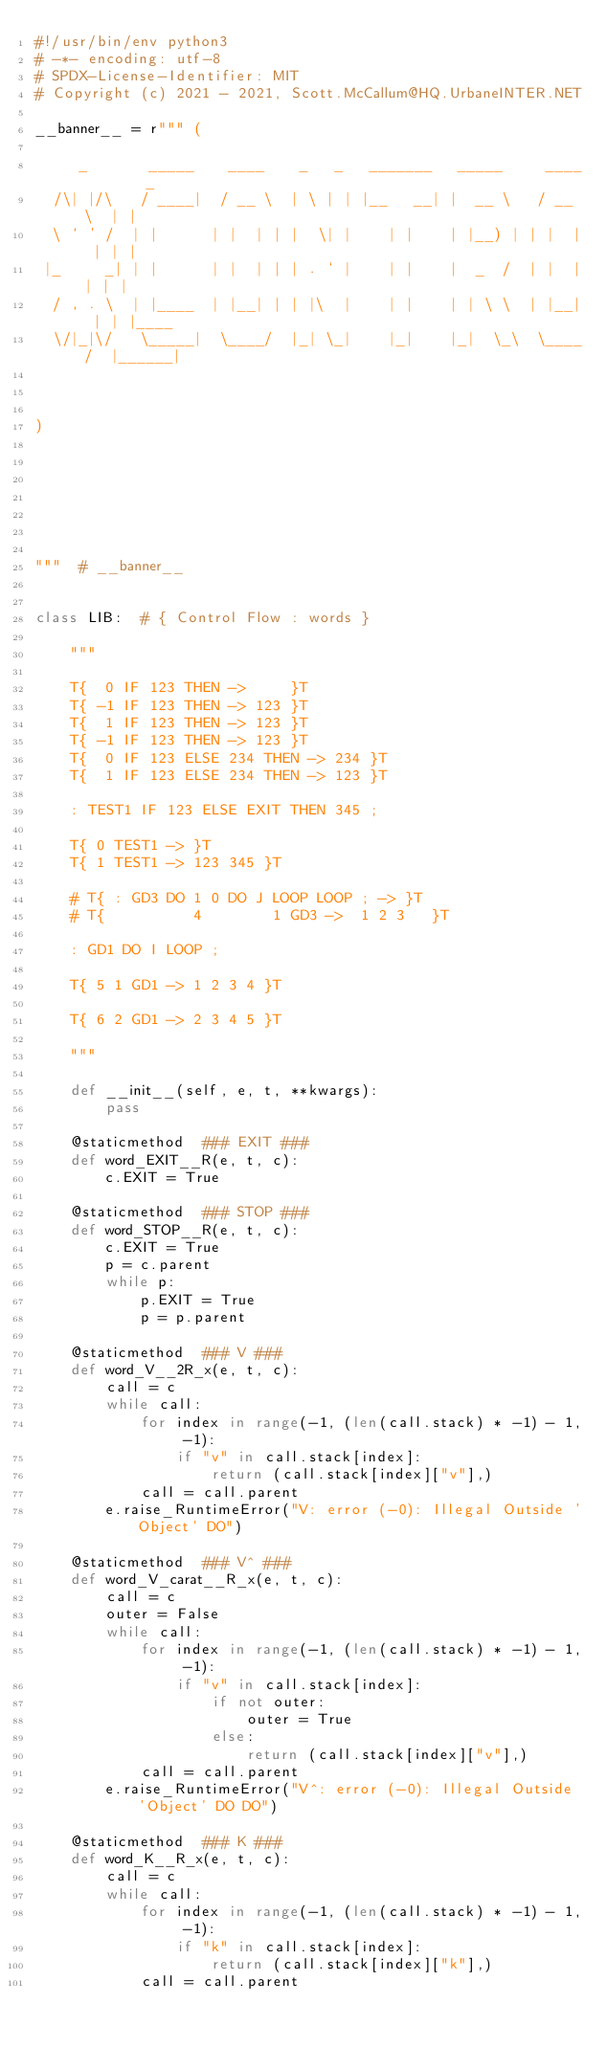Convert code to text. <code><loc_0><loc_0><loc_500><loc_500><_Python_>#!/usr/bin/env python3
# -*- encoding: utf-8
# SPDX-License-Identifier: MIT
# Copyright (c) 2021 - 2021, Scott.McCallum@HQ.UrbaneINTER.NET

__banner__ = r""" (

     _       _____    ____    _   _   _______   _____     ____    _
  /\| |/\   / ____|  / __ \  | \ | | |__   __| |  __ \   / __ \  | |
  \ ` ' /  | |      | |  | | |  \| |    | |    | |__) | | |  | | | |
 |_     _| | |      | |  | | | . ` |    | |    |  _  /  | |  | | | |
  / , . \  | |____  | |__| | | |\  |    | |    | | \ \  | |__| | | |____
  \/|_|\/   \_____|  \____/  |_| \_|    |_|    |_|  \_\  \____/  |______|



)







"""  # __banner__


class LIB:  # { Control Flow : words }

    """

    T{  0 IF 123 THEN ->     }T
    T{ -1 IF 123 THEN -> 123 }T
    T{  1 IF 123 THEN -> 123 }T
    T{ -1 IF 123 THEN -> 123 }T
    T{  0 IF 123 ELSE 234 THEN -> 234 }T
    T{  1 IF 123 ELSE 234 THEN -> 123 }T

    : TEST1 IF 123 ELSE EXIT THEN 345 ;

    T{ 0 TEST1 -> }T
    T{ 1 TEST1 -> 123 345 }T

    # T{ : GD3 DO 1 0 DO J LOOP LOOP ; -> }T
    # T{          4        1 GD3 ->  1 2 3   }T

    : GD1 DO I LOOP ;

    T{ 5 1 GD1 -> 1 2 3 4 }T

    T{ 6 2 GD1 -> 2 3 4 5 }T

    """

    def __init__(self, e, t, **kwargs):
        pass

    @staticmethod  ### EXIT ###
    def word_EXIT__R(e, t, c):
        c.EXIT = True

    @staticmethod  ### STOP ###
    def word_STOP__R(e, t, c):
        c.EXIT = True
        p = c.parent
        while p:
            p.EXIT = True
            p = p.parent

    @staticmethod  ### V ###
    def word_V__2R_x(e, t, c):
        call = c
        while call:
            for index in range(-1, (len(call.stack) * -1) - 1, -1):
                if "v" in call.stack[index]:
                    return (call.stack[index]["v"],)
            call = call.parent
        e.raise_RuntimeError("V: error (-0): Illegal Outside 'Object' DO")

    @staticmethod  ### V^ ###
    def word_V_carat__R_x(e, t, c):
        call = c
        outer = False
        while call:
            for index in range(-1, (len(call.stack) * -1) - 1, -1):
                if "v" in call.stack[index]:
                    if not outer:
                        outer = True
                    else:
                        return (call.stack[index]["v"],)
            call = call.parent
        e.raise_RuntimeError("V^: error (-0): Illegal Outside 'Object' DO DO")

    @staticmethod  ### K ###
    def word_K__R_x(e, t, c):
        call = c
        while call:
            for index in range(-1, (len(call.stack) * -1) - 1, -1):
                if "k" in call.stack[index]:
                    return (call.stack[index]["k"],)
            call = call.parent</code> 